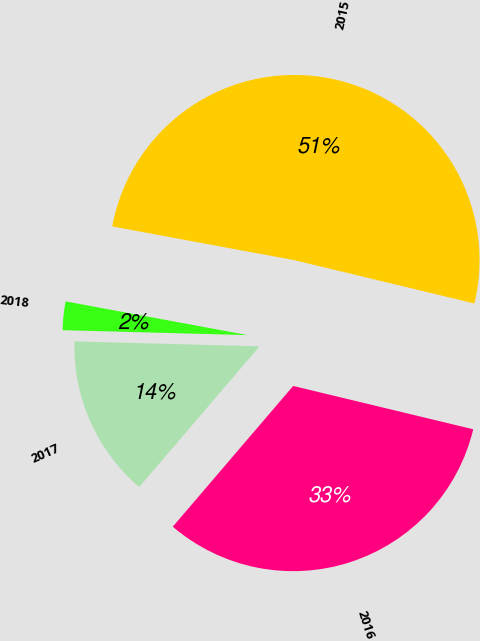<chart> <loc_0><loc_0><loc_500><loc_500><pie_chart><fcel>2015<fcel>2016<fcel>2017<fcel>2018<nl><fcel>50.84%<fcel>32.5%<fcel>14.16%<fcel>2.49%<nl></chart> 